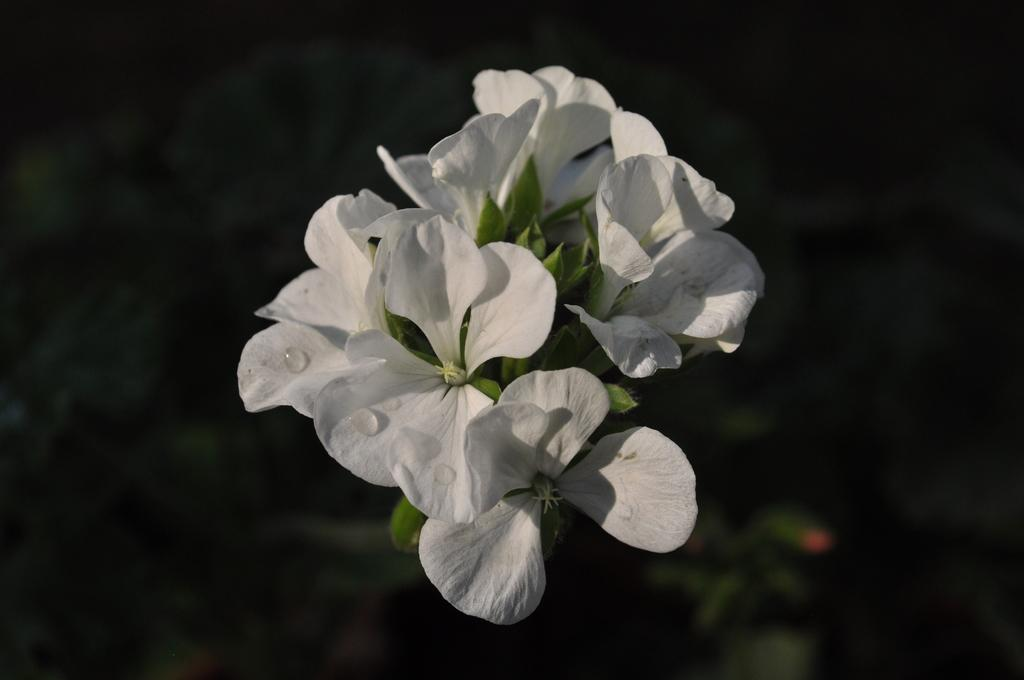What is present on the flowers of the plant in the image? There are water drops on the flowers of a plant in the image. What color are the flowers in the image? The flowers are white in color. How would you describe the background of the image? The background of the image is dark. What caption is written on the plantation in the image? There is no plantation or caption present in the image; it features a plant with water drops on its flowers against a dark background. 